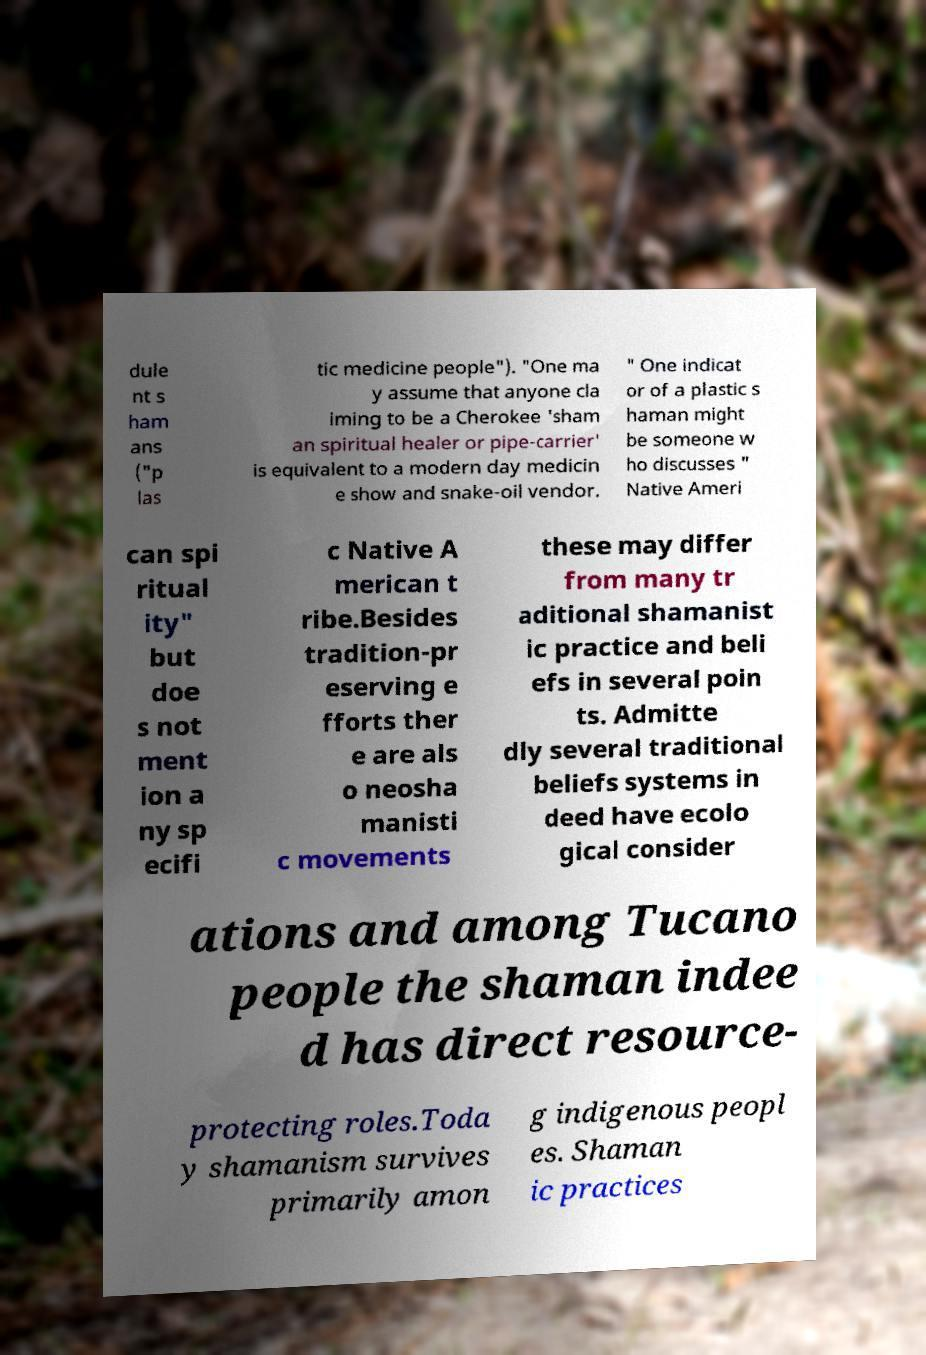I need the written content from this picture converted into text. Can you do that? dule nt s ham ans ("p las tic medicine people"). "One ma y assume that anyone cla iming to be a Cherokee 'sham an spiritual healer or pipe-carrier' is equivalent to a modern day medicin e show and snake-oil vendor. " One indicat or of a plastic s haman might be someone w ho discusses " Native Ameri can spi ritual ity" but doe s not ment ion a ny sp ecifi c Native A merican t ribe.Besides tradition-pr eserving e fforts ther e are als o neosha manisti c movements these may differ from many tr aditional shamanist ic practice and beli efs in several poin ts. Admitte dly several traditional beliefs systems in deed have ecolo gical consider ations and among Tucano people the shaman indee d has direct resource- protecting roles.Toda y shamanism survives primarily amon g indigenous peopl es. Shaman ic practices 